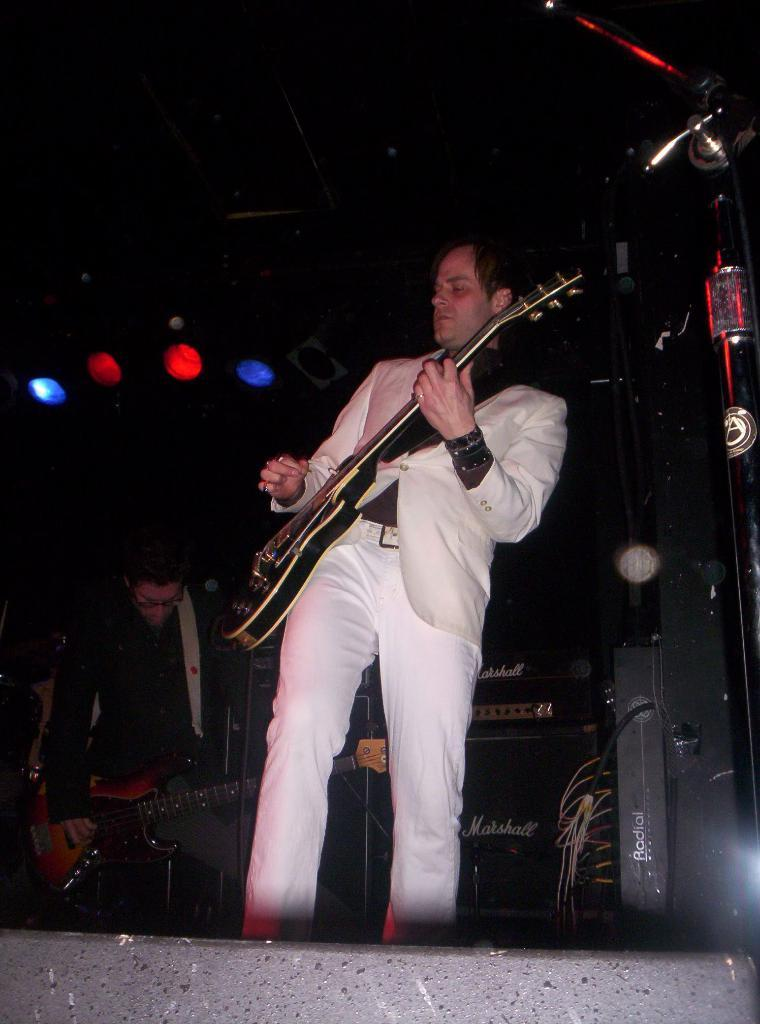What is the man in the image doing with the guitar? The man is holding a guitar and playing it in the image. Are there any other people in the image with a guitar? Yes, there is another man holding a guitar and playing it in the image. How many lights can be seen in the image? There are four lights visible in the image. What type of sugar is being discussed in the meeting between the two men in the image? There is no meeting or discussion of sugar in the image; it features two men playing guitars. What is the relationship between the two men in the image? The provided facts do not mention the relationship between the two men; they are simply playing guitars together. 